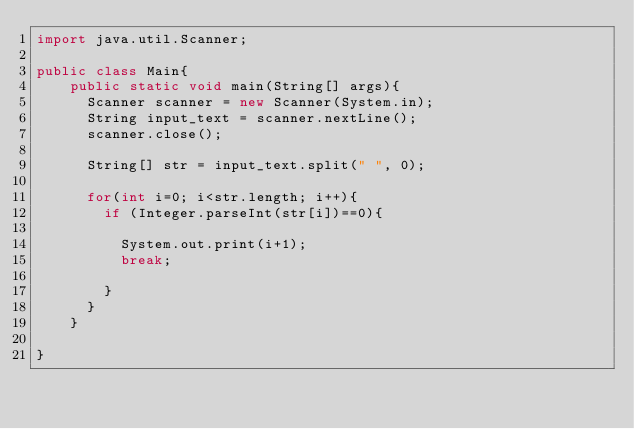Convert code to text. <code><loc_0><loc_0><loc_500><loc_500><_Java_>import java.util.Scanner;

public class Main{
	public static void main(String[] args){
      Scanner scanner = new Scanner(System.in);
      String input_text = scanner.nextLine();
      scanner.close();
      
      String[] str = input_text.split(" ", 0);
      
      for(int i=0; i<str.length; i++){
		if (Integer.parseInt(str[i])==0){
        	
          System.out.print(i+1);
          break;
        
        }
      }
    }

}</code> 